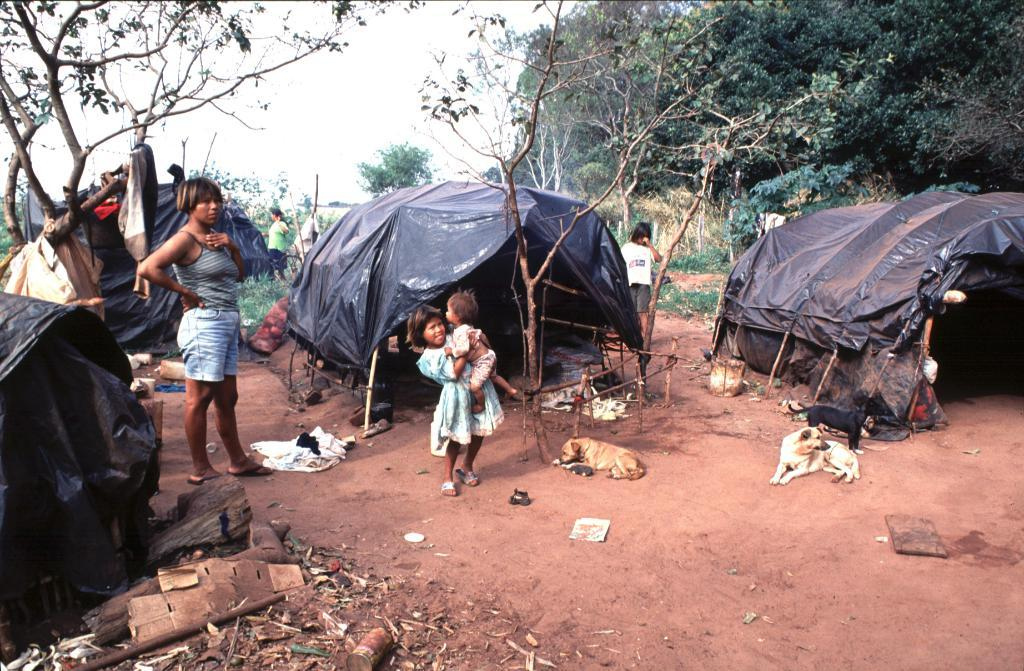What are the people in the image doing? The people in the image are standing on the land. What structures can be seen behind the people? There are tents behind the people. What animals are present in the image? There are stray dogs laying on the floor in the image. What type of vegetation is visible in the background of the image? Trees are visible in the background of the image. What part of the natural environment is visible in the image? The sky is visible in the image. How many nuts are present on the ground in the image? There is no mention of nuts in the image, so it is impossible to determine their presence or quantity. 